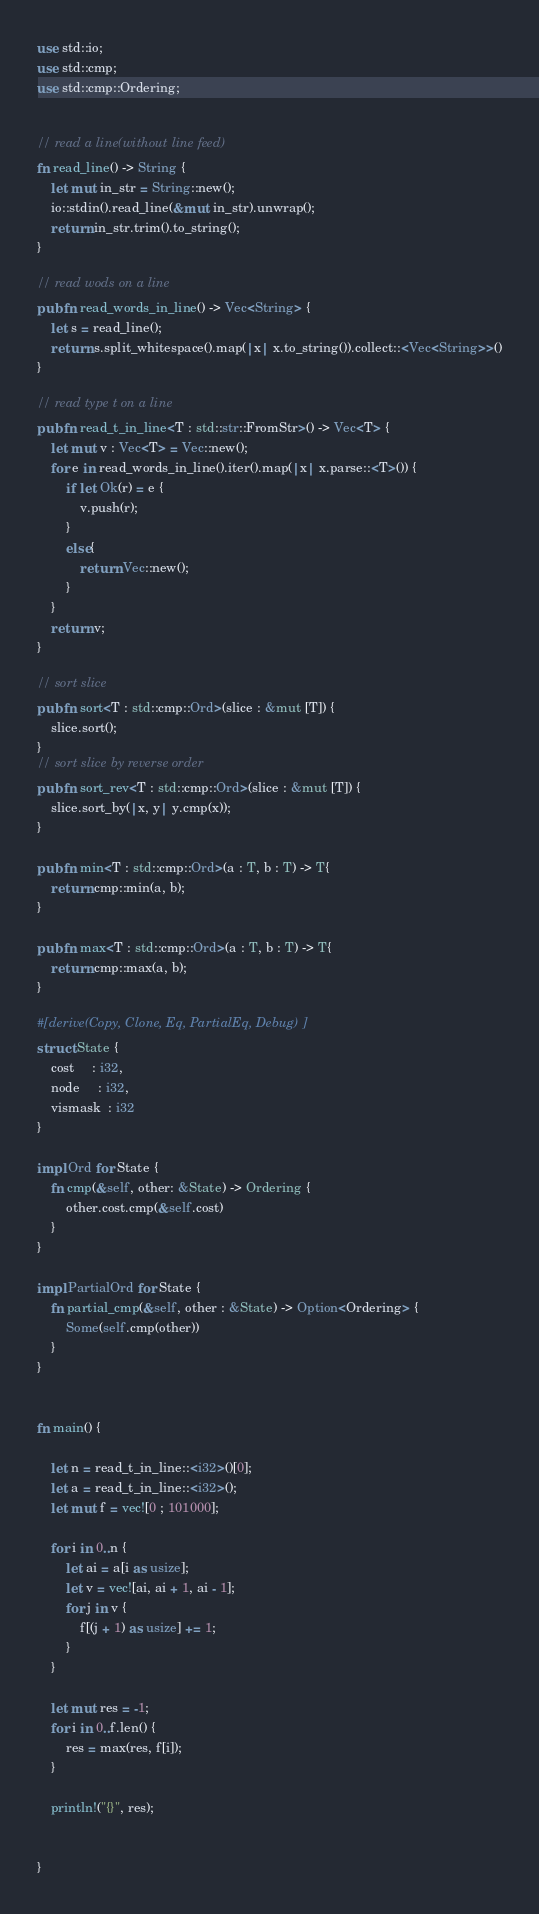Convert code to text. <code><loc_0><loc_0><loc_500><loc_500><_Rust_>use std::io;
use std::cmp;
use std::cmp::Ordering;


// read a line(without line feed)
fn read_line() -> String {
    let mut in_str = String::new();
    io::stdin().read_line(&mut in_str).unwrap();
    return in_str.trim().to_string();
}

// read wods on a line
pub fn read_words_in_line() -> Vec<String> {
    let s = read_line();
    return s.split_whitespace().map(|x| x.to_string()).collect::<Vec<String>>()
}

// read type t on a line
pub fn read_t_in_line<T : std::str::FromStr>() -> Vec<T> {
    let mut v : Vec<T> = Vec::new();
    for e in read_words_in_line().iter().map(|x| x.parse::<T>()) {
        if let Ok(r) = e {
            v.push(r);
        }
        else{
            return Vec::new();
        }
    }
    return v;
}

// sort slice
pub fn sort<T : std::cmp::Ord>(slice : &mut [T]) {
    slice.sort();
}
// sort slice by reverse order
pub fn sort_rev<T : std::cmp::Ord>(slice : &mut [T]) {
    slice.sort_by(|x, y| y.cmp(x));
}

pub fn min<T : std::cmp::Ord>(a : T, b : T) -> T{
    return cmp::min(a, b);
}

pub fn max<T : std::cmp::Ord>(a : T, b : T) -> T{
    return cmp::max(a, b);
}

#[derive(Copy, Clone, Eq, PartialEq, Debug)]
struct State {
    cost     : i32,
    node     : i32,
    vismask  : i32
}

impl Ord for State {
    fn cmp(&self, other: &State) -> Ordering {
        other.cost.cmp(&self.cost)
    }
}

impl PartialOrd for State {
    fn partial_cmp(&self, other : &State) -> Option<Ordering> {
        Some(self.cmp(other))
    }
}


fn main() {
    
    let n = read_t_in_line::<i32>()[0];
    let a = read_t_in_line::<i32>();
    let mut f = vec![0 ; 101000];

    for i in 0..n {
        let ai = a[i as usize];
        let v = vec![ai, ai + 1, ai - 1];
        for j in v {
            f[(j + 1) as usize] += 1;
        }
    }
    
    let mut res = -1;
    for i in 0..f.len() {
        res = max(res, f[i]);
    }

    println!("{}", res);


}
</code> 